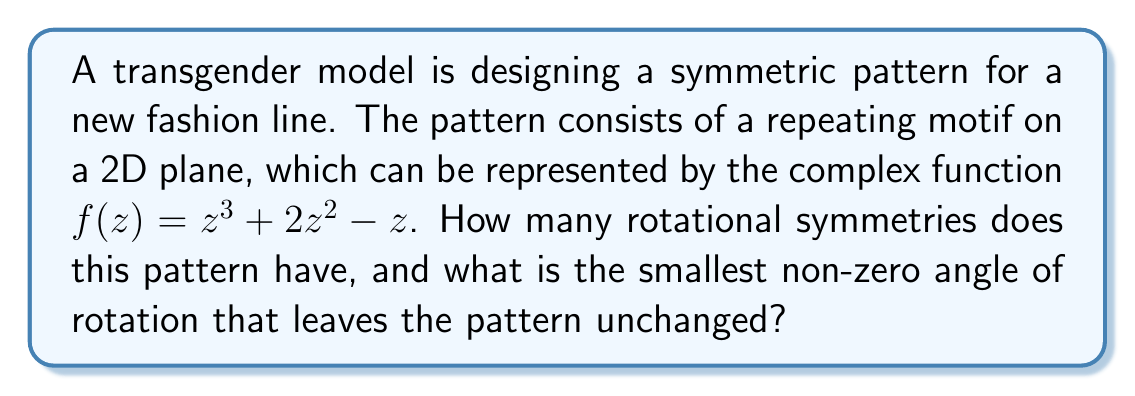Teach me how to tackle this problem. To determine the rotational symmetries of the pattern, we need to analyze the complex function $f(z) = z^3 + 2z^2 - z$.

Step 1: Identify the degree of the polynomial.
The highest power of z in the function is 3, so the degree is 3.

Step 2: Determine the number of rotational symmetries.
For a complex polynomial of degree n, the number of rotational symmetries is equal to n. In this case, n = 3.

Step 3: Calculate the smallest non-zero angle of rotation.
The smallest non-zero angle of rotation is given by $\frac{360°}{n}$.

$$\text{Smallest angle} = \frac{360°}{3} = 120°$$

Step 4: Verify the rotational symmetry.
To confirm, we can check if $f(e^{i\theta}z) = e^{in\theta}f(z)$ holds for $\theta = 120°$.

Let $\omega = e^{i\frac{2\pi}{3}} = e^{i\frac{2\pi}{3}}$ (which corresponds to a 120° rotation).

$$\begin{align}
f(\omega z) &= (\omega z)^3 + 2(\omega z)^2 - \omega z \\
&= \omega^3 z^3 + 2\omega^2 z^2 - \omega z \\
&= z^3 + 2\omega^2 z^2 - \omega z
\end{align}$$

Since $\omega^3 = 1$, $\omega^2 = \omega^{-1} = \overline{\omega}$, and $\omega = -\frac{1}{2} + i\frac{\sqrt{3}}{2}$, we can see that $f(\omega z) = \omega f(z)$, confirming the rotational symmetry.
Answer: 3 rotational symmetries; 120° 